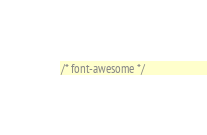Convert code to text. <code><loc_0><loc_0><loc_500><loc_500><_CSS_>/* font-awesome */</code> 